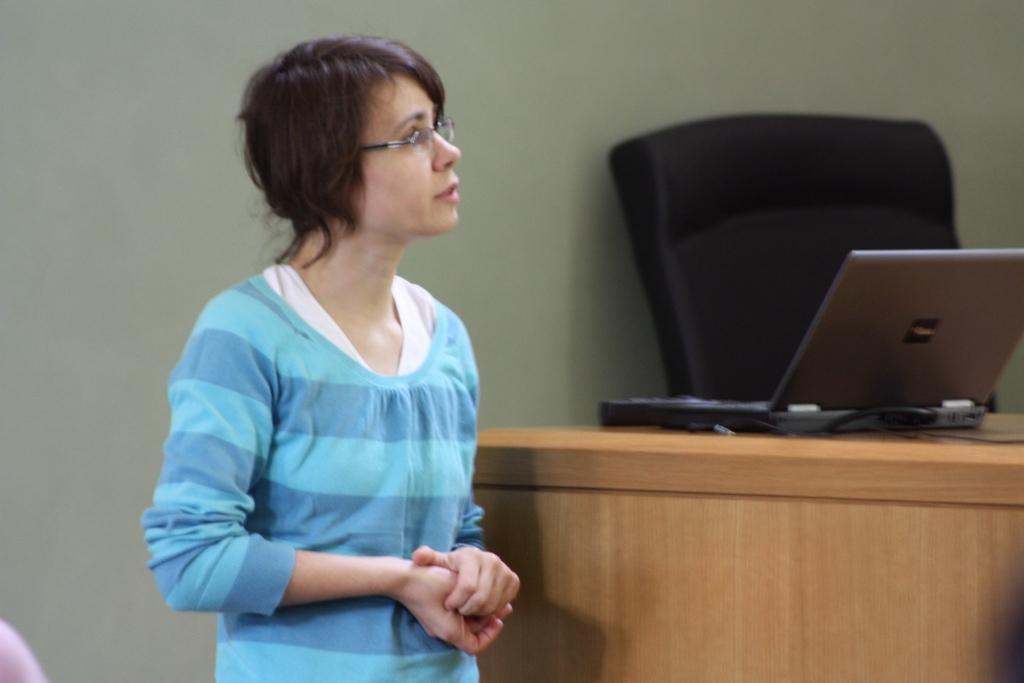In one or two sentences, can you explain what this image depicts? In this image I can see a woman in blue dress and also I can see she is wearing a specs. In the background I can see a laptop and a chair. 